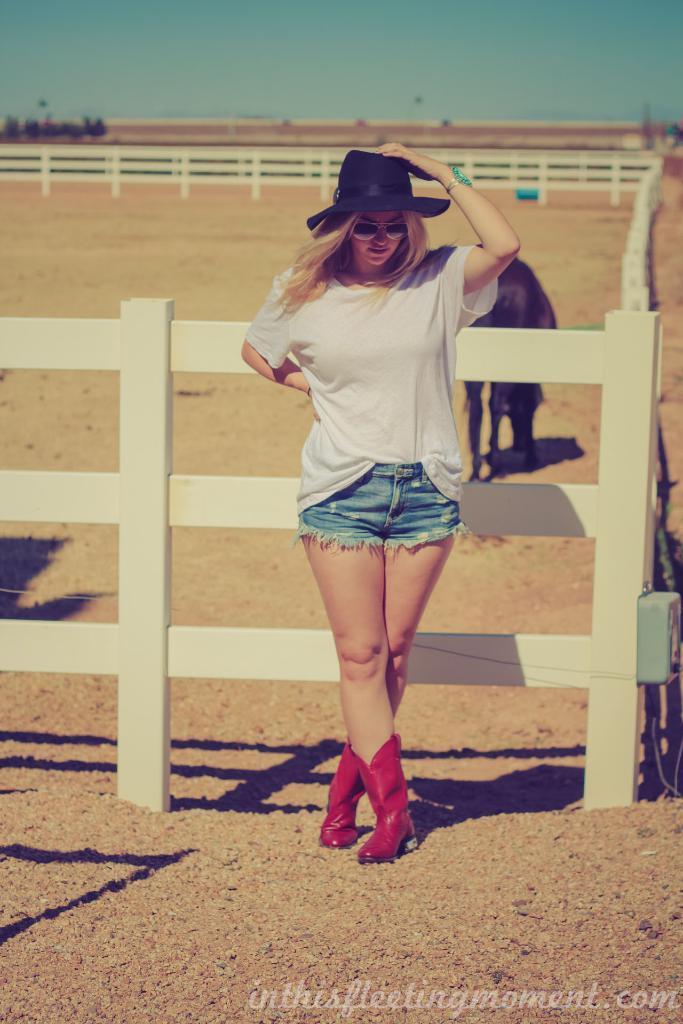Can you describe this image briefly? In this picture there is a girl in the center of the image and there is an animal and a boundary behind her. 